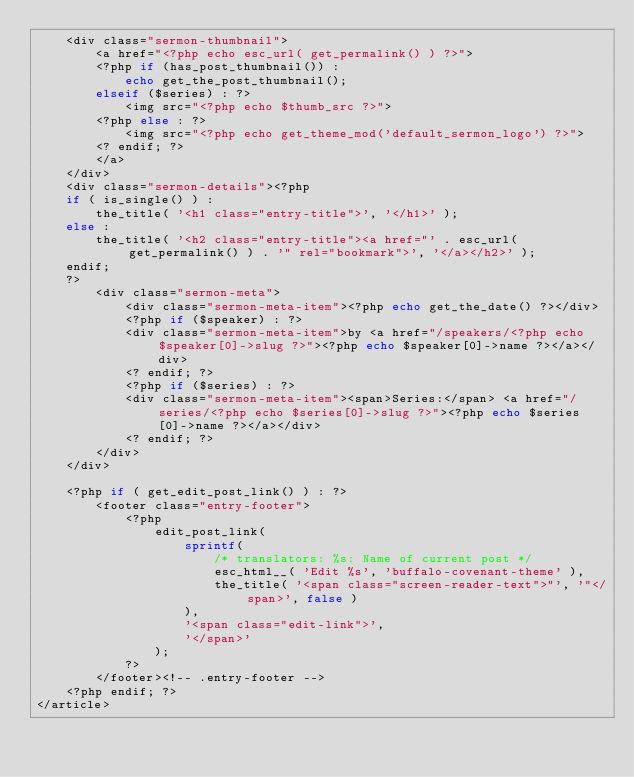Convert code to text. <code><loc_0><loc_0><loc_500><loc_500><_PHP_>	<div class="sermon-thumbnail">
		<a href="<?php echo esc_url( get_permalink() ) ?>">
		<?php if (has_post_thumbnail()) :
			echo get_the_post_thumbnail();
		elseif ($series) : ?>
			<img src="<?php echo $thumb_src ?>">
		<?php else : ?>
			<img src="<?php echo get_theme_mod('default_sermon_logo') ?>">
		<? endif; ?>
		</a>
	</div>
	<div class="sermon-details"><?php
	if ( is_single() ) :
		the_title( '<h1 class="entry-title">', '</h1>' );
	else :
		the_title( '<h2 class="entry-title"><a href="' . esc_url( get_permalink() ) . '" rel="bookmark">', '</a></h2>' );
	endif;
	?>
		<div class="sermon-meta">
			<div class="sermon-meta-item"><?php echo get_the_date() ?></div>
			<?php if ($speaker) : ?>
			<div class="sermon-meta-item">by <a href="/speakers/<?php echo $speaker[0]->slug ?>"><?php echo $speaker[0]->name ?></a></div>
			<? endif; ?>
			<?php if ($series) : ?>
			<div class="sermon-meta-item"><span>Series:</span> <a href="/series/<?php echo $series[0]->slug ?>"><?php echo $series[0]->name ?></a></div>
			<? endif; ?>
		</div>
	</div>

	<?php if ( get_edit_post_link() ) : ?>
		<footer class="entry-footer">
			<?php
				edit_post_link(
					sprintf(
						/* translators: %s: Name of current post */
						esc_html__( 'Edit %s', 'buffalo-covenant-theme' ),
						the_title( '<span class="screen-reader-text">"', '"</span>', false )
					),
					'<span class="edit-link">',
					'</span>'
				);
			?>
		</footer><!-- .entry-footer -->
	<?php endif; ?>
</article></code> 